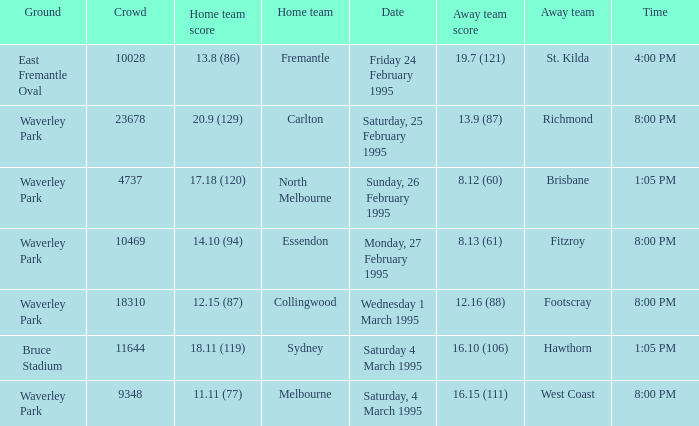Name the total number of grounds for essendon 1.0. 